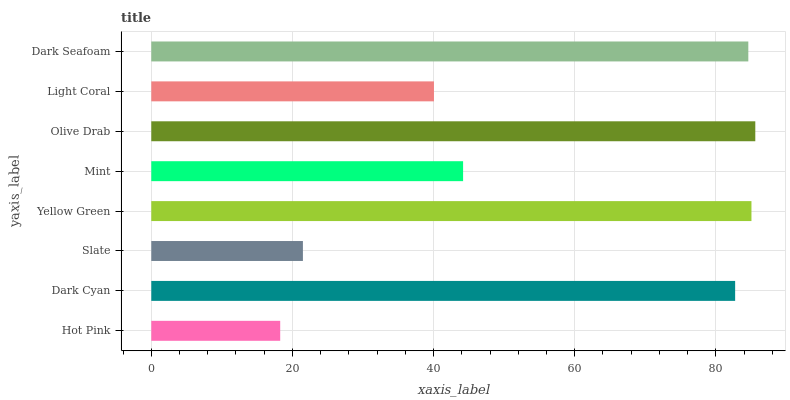Is Hot Pink the minimum?
Answer yes or no. Yes. Is Olive Drab the maximum?
Answer yes or no. Yes. Is Dark Cyan the minimum?
Answer yes or no. No. Is Dark Cyan the maximum?
Answer yes or no. No. Is Dark Cyan greater than Hot Pink?
Answer yes or no. Yes. Is Hot Pink less than Dark Cyan?
Answer yes or no. Yes. Is Hot Pink greater than Dark Cyan?
Answer yes or no. No. Is Dark Cyan less than Hot Pink?
Answer yes or no. No. Is Dark Cyan the high median?
Answer yes or no. Yes. Is Mint the low median?
Answer yes or no. Yes. Is Dark Seafoam the high median?
Answer yes or no. No. Is Olive Drab the low median?
Answer yes or no. No. 